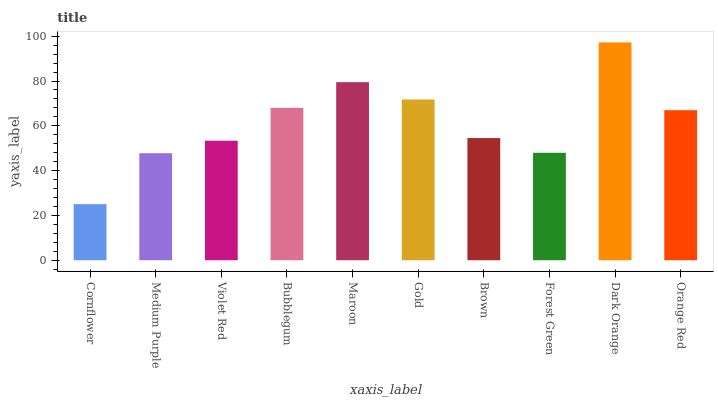Is Cornflower the minimum?
Answer yes or no. Yes. Is Dark Orange the maximum?
Answer yes or no. Yes. Is Medium Purple the minimum?
Answer yes or no. No. Is Medium Purple the maximum?
Answer yes or no. No. Is Medium Purple greater than Cornflower?
Answer yes or no. Yes. Is Cornflower less than Medium Purple?
Answer yes or no. Yes. Is Cornflower greater than Medium Purple?
Answer yes or no. No. Is Medium Purple less than Cornflower?
Answer yes or no. No. Is Orange Red the high median?
Answer yes or no. Yes. Is Brown the low median?
Answer yes or no. Yes. Is Forest Green the high median?
Answer yes or no. No. Is Violet Red the low median?
Answer yes or no. No. 